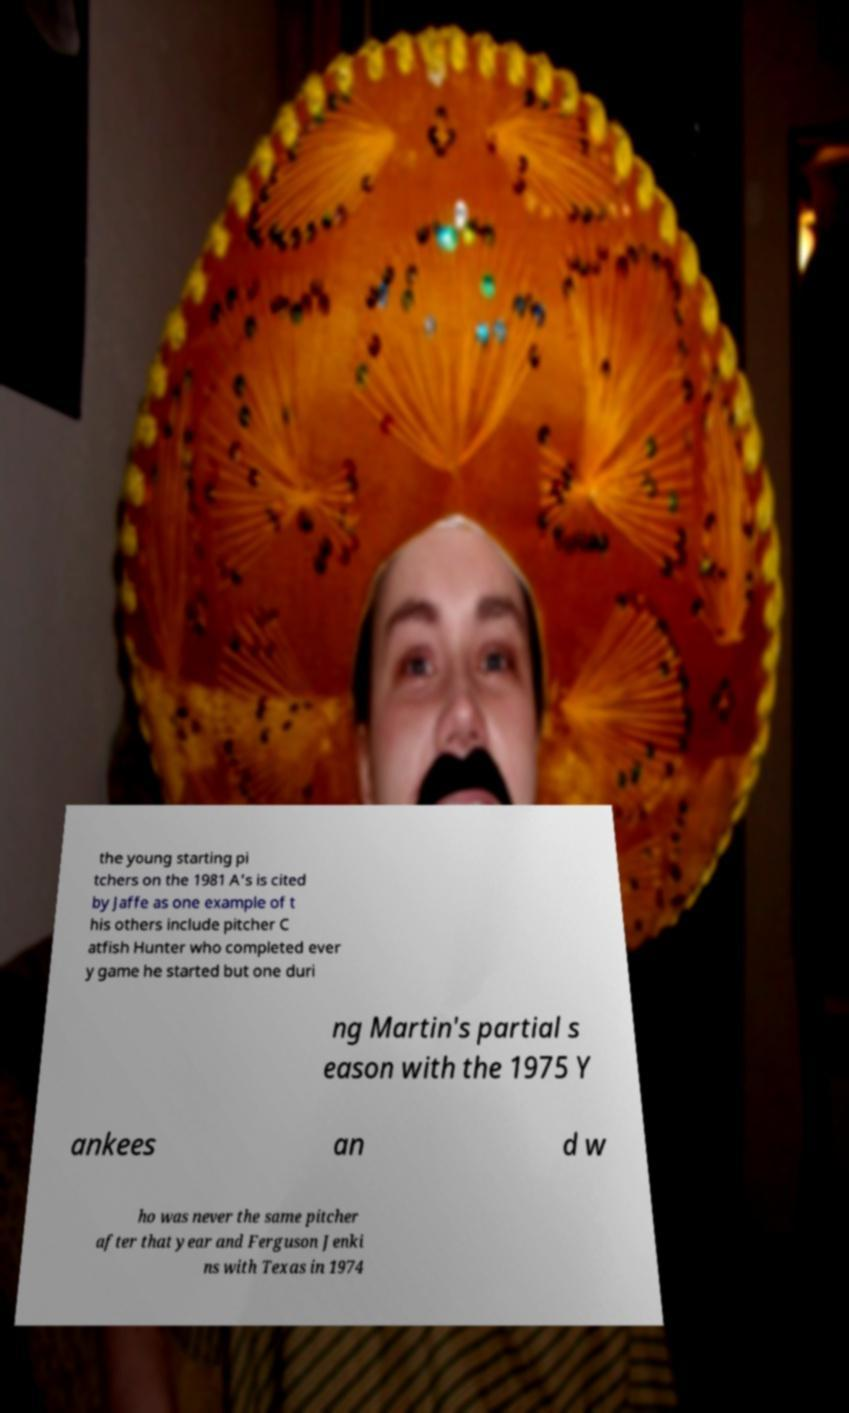Please identify and transcribe the text found in this image. the young starting pi tchers on the 1981 A's is cited by Jaffe as one example of t his others include pitcher C atfish Hunter who completed ever y game he started but one duri ng Martin's partial s eason with the 1975 Y ankees an d w ho was never the same pitcher after that year and Ferguson Jenki ns with Texas in 1974 